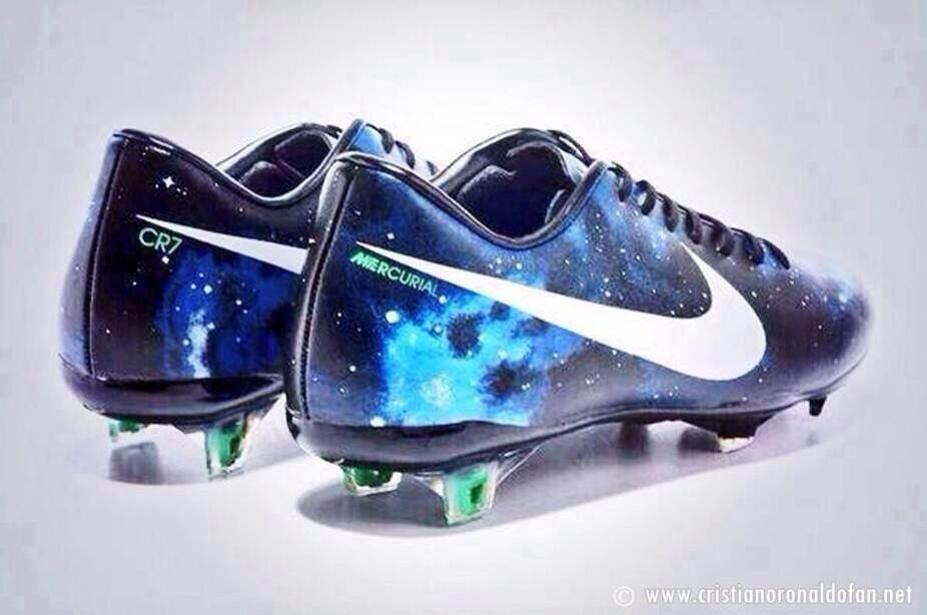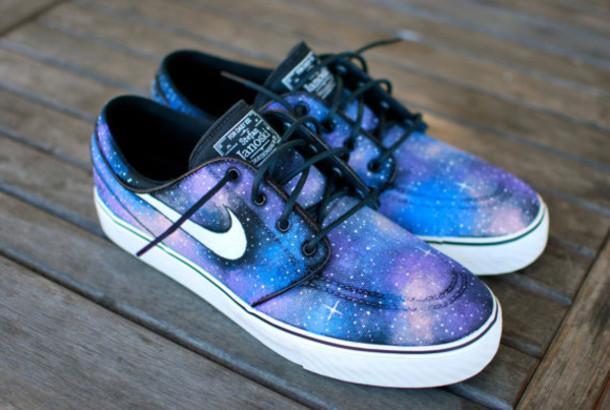The first image is the image on the left, the second image is the image on the right. For the images displayed, is the sentence "One pair of casual shoes has a small black tag sticking up from the back of each shoe." factually correct? Answer yes or no. No. 